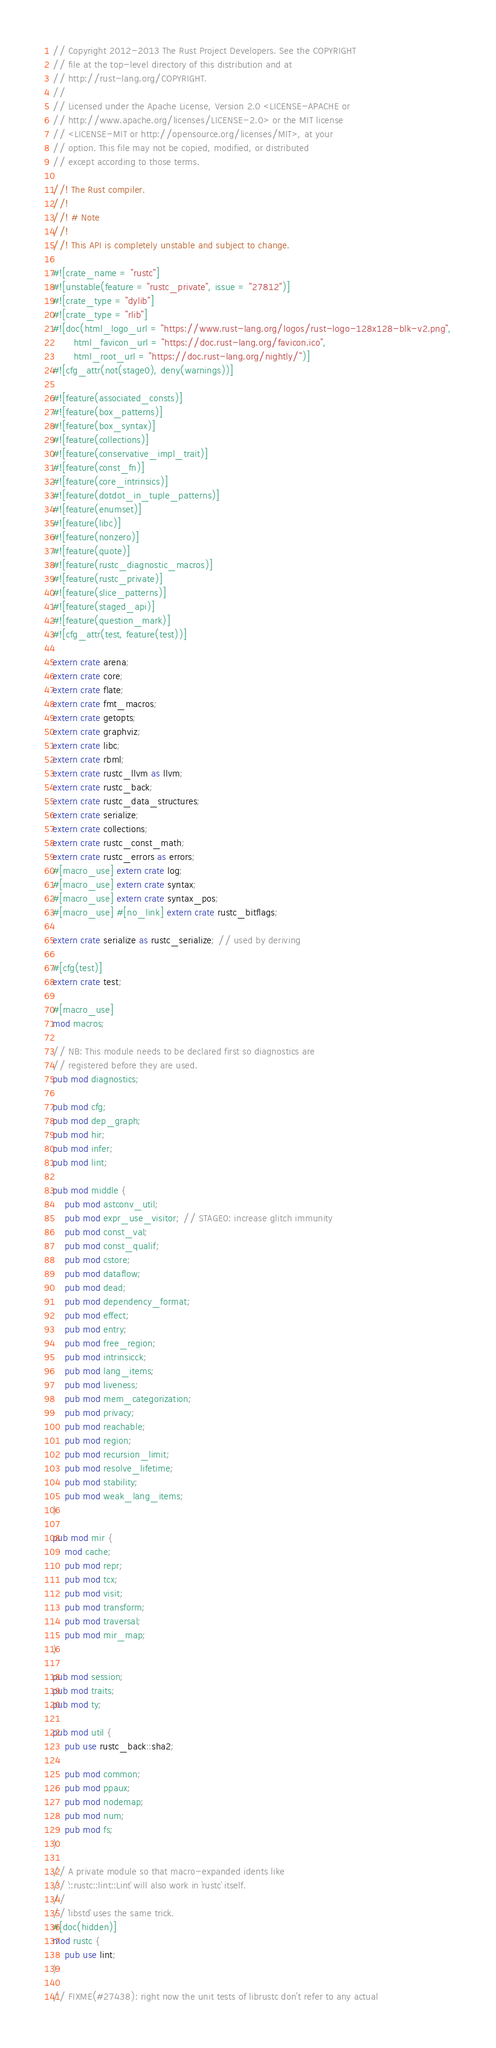Convert code to text. <code><loc_0><loc_0><loc_500><loc_500><_Rust_>// Copyright 2012-2013 The Rust Project Developers. See the COPYRIGHT
// file at the top-level directory of this distribution and at
// http://rust-lang.org/COPYRIGHT.
//
// Licensed under the Apache License, Version 2.0 <LICENSE-APACHE or
// http://www.apache.org/licenses/LICENSE-2.0> or the MIT license
// <LICENSE-MIT or http://opensource.org/licenses/MIT>, at your
// option. This file may not be copied, modified, or distributed
// except according to those terms.

//! The Rust compiler.
//!
//! # Note
//!
//! This API is completely unstable and subject to change.

#![crate_name = "rustc"]
#![unstable(feature = "rustc_private", issue = "27812")]
#![crate_type = "dylib"]
#![crate_type = "rlib"]
#![doc(html_logo_url = "https://www.rust-lang.org/logos/rust-logo-128x128-blk-v2.png",
       html_favicon_url = "https://doc.rust-lang.org/favicon.ico",
       html_root_url = "https://doc.rust-lang.org/nightly/")]
#![cfg_attr(not(stage0), deny(warnings))]

#![feature(associated_consts)]
#![feature(box_patterns)]
#![feature(box_syntax)]
#![feature(collections)]
#![feature(conservative_impl_trait)]
#![feature(const_fn)]
#![feature(core_intrinsics)]
#![feature(dotdot_in_tuple_patterns)]
#![feature(enumset)]
#![feature(libc)]
#![feature(nonzero)]
#![feature(quote)]
#![feature(rustc_diagnostic_macros)]
#![feature(rustc_private)]
#![feature(slice_patterns)]
#![feature(staged_api)]
#![feature(question_mark)]
#![cfg_attr(test, feature(test))]

extern crate arena;
extern crate core;
extern crate flate;
extern crate fmt_macros;
extern crate getopts;
extern crate graphviz;
extern crate libc;
extern crate rbml;
extern crate rustc_llvm as llvm;
extern crate rustc_back;
extern crate rustc_data_structures;
extern crate serialize;
extern crate collections;
extern crate rustc_const_math;
extern crate rustc_errors as errors;
#[macro_use] extern crate log;
#[macro_use] extern crate syntax;
#[macro_use] extern crate syntax_pos;
#[macro_use] #[no_link] extern crate rustc_bitflags;

extern crate serialize as rustc_serialize; // used by deriving

#[cfg(test)]
extern crate test;

#[macro_use]
mod macros;

// NB: This module needs to be declared first so diagnostics are
// registered before they are used.
pub mod diagnostics;

pub mod cfg;
pub mod dep_graph;
pub mod hir;
pub mod infer;
pub mod lint;

pub mod middle {
    pub mod astconv_util;
    pub mod expr_use_visitor; // STAGE0: increase glitch immunity
    pub mod const_val;
    pub mod const_qualif;
    pub mod cstore;
    pub mod dataflow;
    pub mod dead;
    pub mod dependency_format;
    pub mod effect;
    pub mod entry;
    pub mod free_region;
    pub mod intrinsicck;
    pub mod lang_items;
    pub mod liveness;
    pub mod mem_categorization;
    pub mod privacy;
    pub mod reachable;
    pub mod region;
    pub mod recursion_limit;
    pub mod resolve_lifetime;
    pub mod stability;
    pub mod weak_lang_items;
}

pub mod mir {
    mod cache;
    pub mod repr;
    pub mod tcx;
    pub mod visit;
    pub mod transform;
    pub mod traversal;
    pub mod mir_map;
}

pub mod session;
pub mod traits;
pub mod ty;

pub mod util {
    pub use rustc_back::sha2;

    pub mod common;
    pub mod ppaux;
    pub mod nodemap;
    pub mod num;
    pub mod fs;
}

// A private module so that macro-expanded idents like
// `::rustc::lint::Lint` will also work in `rustc` itself.
//
// `libstd` uses the same trick.
#[doc(hidden)]
mod rustc {
    pub use lint;
}

// FIXME(#27438): right now the unit tests of librustc don't refer to any actual</code> 